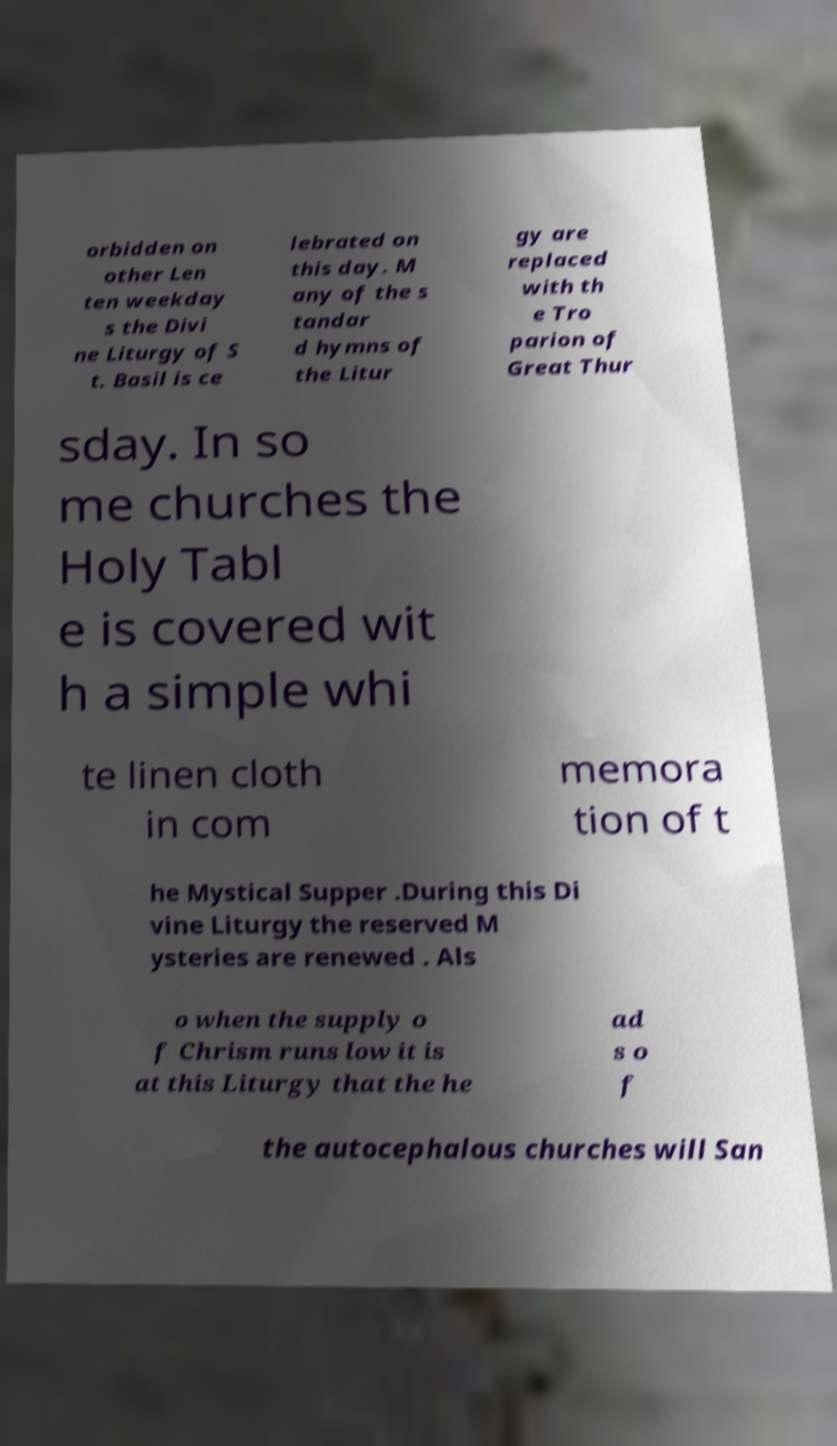What messages or text are displayed in this image? I need them in a readable, typed format. orbidden on other Len ten weekday s the Divi ne Liturgy of S t. Basil is ce lebrated on this day. M any of the s tandar d hymns of the Litur gy are replaced with th e Tro parion of Great Thur sday. In so me churches the Holy Tabl e is covered wit h a simple whi te linen cloth in com memora tion of t he Mystical Supper .During this Di vine Liturgy the reserved M ysteries are renewed . Als o when the supply o f Chrism runs low it is at this Liturgy that the he ad s o f the autocephalous churches will San 